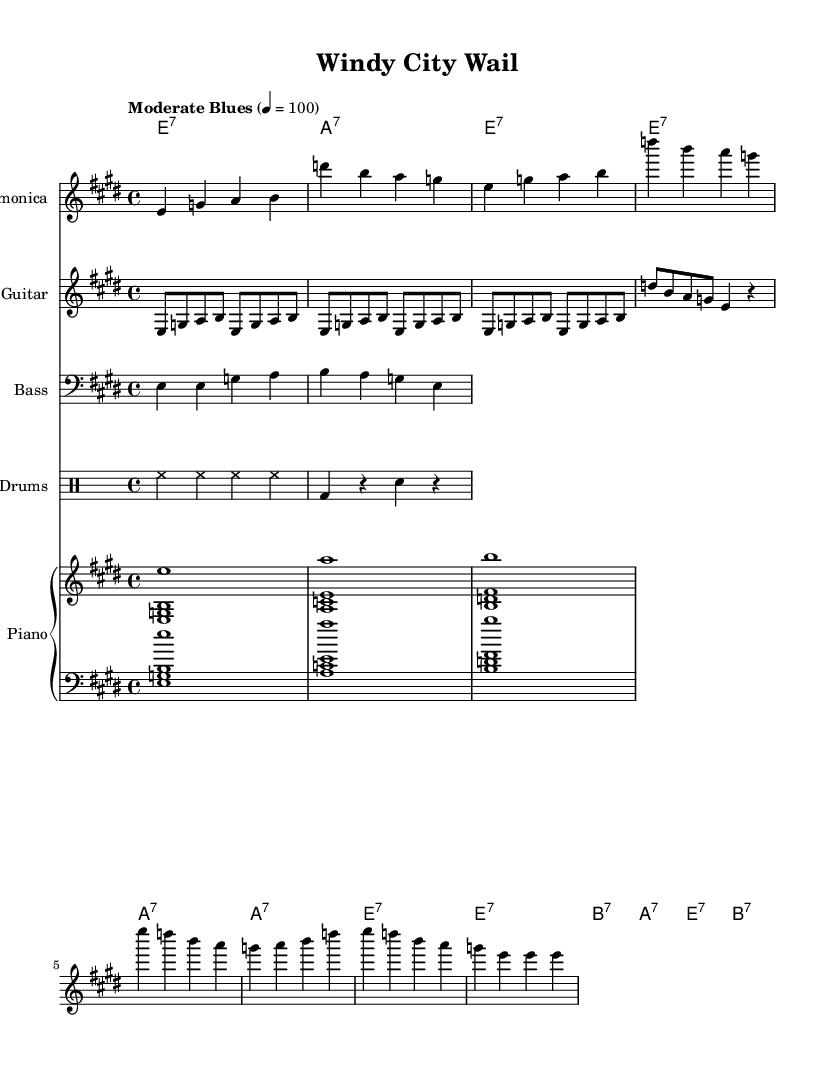What is the key signature of this music? The key signature is E major, which has four sharps: F#, C#, G#, and D#. This can be identified at the beginning of the staff in the key signature section.
Answer: E major What is the time signature of this piece? The time signature shown at the beginning of the sheet music is 4/4, meaning there are four beats per measure and a quarter note gets one beat. This is clearly indicated in the time signature section at the start.
Answer: 4/4 What is the tempo indicated for this piece? The tempo marking is "Moderate Blues" with a metronome marking of 100 beats per minute. This is explicitly noted at the beginning in the tempo instruction.
Answer: Moderate Blues, 100 How many measures are in the harmonica solo? The harmonica solo consists of eight measures, which can be counted by looking at the barlines separating the musical phrases.
Answer: Eight measures What are the chord progressions used in this blues piece? The chord progressions consist of E7, A7, and B7, primarily following a standard twelve-bar blues format with repetitions. These chords are written in the chord names section corresponding to the rhythmic patterns.
Answer: E7, A7, B7 Which instrument has the main melodic representation in this sheet music? The harmonica is highlighted as the main melodic instrument, as its part is written in the top staff and features the primary melody throughout the piece.
Answer: Harmonica What is the genre of this music piece? The music is categorized as classic Chicago blues since it features typical elements of the genre, including prominent use of the harmonica and characteristic chord progressions. This can be inferred from the title and style presented in the sheet music.
Answer: Classic Chicago blues 